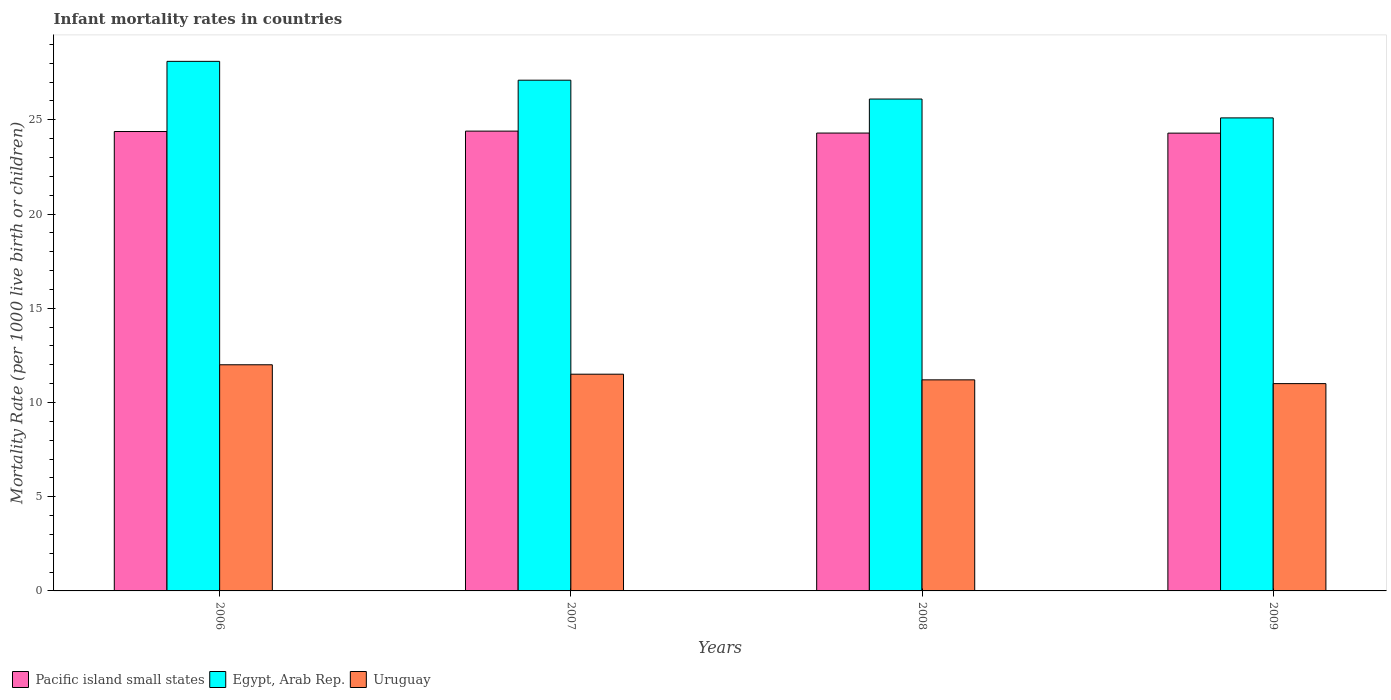How many different coloured bars are there?
Ensure brevity in your answer.  3. How many groups of bars are there?
Your answer should be compact. 4. Are the number of bars on each tick of the X-axis equal?
Offer a very short reply. Yes. How many bars are there on the 2nd tick from the left?
Make the answer very short. 3. What is the label of the 3rd group of bars from the left?
Offer a terse response. 2008. In how many cases, is the number of bars for a given year not equal to the number of legend labels?
Provide a short and direct response. 0. What is the infant mortality rate in Egypt, Arab Rep. in 2007?
Your answer should be very brief. 27.1. Across all years, what is the maximum infant mortality rate in Uruguay?
Offer a very short reply. 12. Across all years, what is the minimum infant mortality rate in Pacific island small states?
Ensure brevity in your answer.  24.29. In which year was the infant mortality rate in Pacific island small states maximum?
Provide a succinct answer. 2007. What is the total infant mortality rate in Pacific island small states in the graph?
Your response must be concise. 97.36. What is the difference between the infant mortality rate in Pacific island small states in 2007 and that in 2008?
Offer a very short reply. 0.1. What is the difference between the infant mortality rate in Egypt, Arab Rep. in 2008 and the infant mortality rate in Pacific island small states in 2009?
Make the answer very short. 1.81. What is the average infant mortality rate in Uruguay per year?
Your response must be concise. 11.43. In the year 2007, what is the difference between the infant mortality rate in Pacific island small states and infant mortality rate in Egypt, Arab Rep.?
Make the answer very short. -2.7. What is the ratio of the infant mortality rate in Egypt, Arab Rep. in 2006 to that in 2008?
Provide a short and direct response. 1.08. Is the infant mortality rate in Egypt, Arab Rep. in 2007 less than that in 2008?
Offer a very short reply. No. What is the difference between the highest and the second highest infant mortality rate in Uruguay?
Offer a very short reply. 0.5. What is the difference between the highest and the lowest infant mortality rate in Pacific island small states?
Give a very brief answer. 0.11. In how many years, is the infant mortality rate in Egypt, Arab Rep. greater than the average infant mortality rate in Egypt, Arab Rep. taken over all years?
Offer a terse response. 2. Is the sum of the infant mortality rate in Pacific island small states in 2008 and 2009 greater than the maximum infant mortality rate in Uruguay across all years?
Offer a very short reply. Yes. What does the 1st bar from the left in 2009 represents?
Give a very brief answer. Pacific island small states. What does the 1st bar from the right in 2007 represents?
Make the answer very short. Uruguay. How many bars are there?
Make the answer very short. 12. What is the difference between two consecutive major ticks on the Y-axis?
Ensure brevity in your answer.  5. Does the graph contain any zero values?
Offer a very short reply. No. Does the graph contain grids?
Offer a terse response. No. How many legend labels are there?
Give a very brief answer. 3. What is the title of the graph?
Offer a very short reply. Infant mortality rates in countries. Does "United Kingdom" appear as one of the legend labels in the graph?
Your answer should be very brief. No. What is the label or title of the X-axis?
Your answer should be very brief. Years. What is the label or title of the Y-axis?
Offer a very short reply. Mortality Rate (per 1000 live birth or children). What is the Mortality Rate (per 1000 live birth or children) of Pacific island small states in 2006?
Ensure brevity in your answer.  24.38. What is the Mortality Rate (per 1000 live birth or children) of Egypt, Arab Rep. in 2006?
Provide a succinct answer. 28.1. What is the Mortality Rate (per 1000 live birth or children) in Uruguay in 2006?
Provide a short and direct response. 12. What is the Mortality Rate (per 1000 live birth or children) in Pacific island small states in 2007?
Your response must be concise. 24.4. What is the Mortality Rate (per 1000 live birth or children) of Egypt, Arab Rep. in 2007?
Offer a very short reply. 27.1. What is the Mortality Rate (per 1000 live birth or children) in Pacific island small states in 2008?
Your answer should be compact. 24.3. What is the Mortality Rate (per 1000 live birth or children) in Egypt, Arab Rep. in 2008?
Provide a short and direct response. 26.1. What is the Mortality Rate (per 1000 live birth or children) in Uruguay in 2008?
Your response must be concise. 11.2. What is the Mortality Rate (per 1000 live birth or children) of Pacific island small states in 2009?
Ensure brevity in your answer.  24.29. What is the Mortality Rate (per 1000 live birth or children) in Egypt, Arab Rep. in 2009?
Provide a succinct answer. 25.1. Across all years, what is the maximum Mortality Rate (per 1000 live birth or children) of Pacific island small states?
Provide a succinct answer. 24.4. Across all years, what is the maximum Mortality Rate (per 1000 live birth or children) in Egypt, Arab Rep.?
Provide a succinct answer. 28.1. Across all years, what is the maximum Mortality Rate (per 1000 live birth or children) in Uruguay?
Your answer should be compact. 12. Across all years, what is the minimum Mortality Rate (per 1000 live birth or children) in Pacific island small states?
Give a very brief answer. 24.29. Across all years, what is the minimum Mortality Rate (per 1000 live birth or children) of Egypt, Arab Rep.?
Your answer should be compact. 25.1. What is the total Mortality Rate (per 1000 live birth or children) in Pacific island small states in the graph?
Your response must be concise. 97.36. What is the total Mortality Rate (per 1000 live birth or children) in Egypt, Arab Rep. in the graph?
Your answer should be compact. 106.4. What is the total Mortality Rate (per 1000 live birth or children) in Uruguay in the graph?
Your response must be concise. 45.7. What is the difference between the Mortality Rate (per 1000 live birth or children) of Pacific island small states in 2006 and that in 2007?
Your answer should be compact. -0.02. What is the difference between the Mortality Rate (per 1000 live birth or children) in Uruguay in 2006 and that in 2007?
Provide a short and direct response. 0.5. What is the difference between the Mortality Rate (per 1000 live birth or children) of Pacific island small states in 2006 and that in 2008?
Keep it short and to the point. 0.08. What is the difference between the Mortality Rate (per 1000 live birth or children) in Pacific island small states in 2006 and that in 2009?
Keep it short and to the point. 0.09. What is the difference between the Mortality Rate (per 1000 live birth or children) of Egypt, Arab Rep. in 2006 and that in 2009?
Offer a terse response. 3. What is the difference between the Mortality Rate (per 1000 live birth or children) in Pacific island small states in 2007 and that in 2008?
Provide a succinct answer. 0.1. What is the difference between the Mortality Rate (per 1000 live birth or children) of Uruguay in 2007 and that in 2008?
Keep it short and to the point. 0.3. What is the difference between the Mortality Rate (per 1000 live birth or children) of Pacific island small states in 2007 and that in 2009?
Keep it short and to the point. 0.11. What is the difference between the Mortality Rate (per 1000 live birth or children) of Egypt, Arab Rep. in 2007 and that in 2009?
Give a very brief answer. 2. What is the difference between the Mortality Rate (per 1000 live birth or children) of Uruguay in 2007 and that in 2009?
Your response must be concise. 0.5. What is the difference between the Mortality Rate (per 1000 live birth or children) of Pacific island small states in 2008 and that in 2009?
Ensure brevity in your answer.  0. What is the difference between the Mortality Rate (per 1000 live birth or children) in Egypt, Arab Rep. in 2008 and that in 2009?
Offer a very short reply. 1. What is the difference between the Mortality Rate (per 1000 live birth or children) in Uruguay in 2008 and that in 2009?
Provide a succinct answer. 0.2. What is the difference between the Mortality Rate (per 1000 live birth or children) in Pacific island small states in 2006 and the Mortality Rate (per 1000 live birth or children) in Egypt, Arab Rep. in 2007?
Give a very brief answer. -2.72. What is the difference between the Mortality Rate (per 1000 live birth or children) in Pacific island small states in 2006 and the Mortality Rate (per 1000 live birth or children) in Uruguay in 2007?
Provide a short and direct response. 12.88. What is the difference between the Mortality Rate (per 1000 live birth or children) in Egypt, Arab Rep. in 2006 and the Mortality Rate (per 1000 live birth or children) in Uruguay in 2007?
Offer a very short reply. 16.6. What is the difference between the Mortality Rate (per 1000 live birth or children) in Pacific island small states in 2006 and the Mortality Rate (per 1000 live birth or children) in Egypt, Arab Rep. in 2008?
Offer a terse response. -1.72. What is the difference between the Mortality Rate (per 1000 live birth or children) of Pacific island small states in 2006 and the Mortality Rate (per 1000 live birth or children) of Uruguay in 2008?
Provide a succinct answer. 13.18. What is the difference between the Mortality Rate (per 1000 live birth or children) of Pacific island small states in 2006 and the Mortality Rate (per 1000 live birth or children) of Egypt, Arab Rep. in 2009?
Ensure brevity in your answer.  -0.72. What is the difference between the Mortality Rate (per 1000 live birth or children) of Pacific island small states in 2006 and the Mortality Rate (per 1000 live birth or children) of Uruguay in 2009?
Provide a short and direct response. 13.38. What is the difference between the Mortality Rate (per 1000 live birth or children) in Pacific island small states in 2007 and the Mortality Rate (per 1000 live birth or children) in Egypt, Arab Rep. in 2008?
Give a very brief answer. -1.7. What is the difference between the Mortality Rate (per 1000 live birth or children) in Pacific island small states in 2007 and the Mortality Rate (per 1000 live birth or children) in Uruguay in 2008?
Ensure brevity in your answer.  13.2. What is the difference between the Mortality Rate (per 1000 live birth or children) in Pacific island small states in 2007 and the Mortality Rate (per 1000 live birth or children) in Egypt, Arab Rep. in 2009?
Your response must be concise. -0.7. What is the difference between the Mortality Rate (per 1000 live birth or children) of Pacific island small states in 2007 and the Mortality Rate (per 1000 live birth or children) of Uruguay in 2009?
Give a very brief answer. 13.4. What is the difference between the Mortality Rate (per 1000 live birth or children) of Egypt, Arab Rep. in 2007 and the Mortality Rate (per 1000 live birth or children) of Uruguay in 2009?
Ensure brevity in your answer.  16.1. What is the difference between the Mortality Rate (per 1000 live birth or children) of Pacific island small states in 2008 and the Mortality Rate (per 1000 live birth or children) of Egypt, Arab Rep. in 2009?
Give a very brief answer. -0.8. What is the difference between the Mortality Rate (per 1000 live birth or children) of Pacific island small states in 2008 and the Mortality Rate (per 1000 live birth or children) of Uruguay in 2009?
Give a very brief answer. 13.3. What is the average Mortality Rate (per 1000 live birth or children) of Pacific island small states per year?
Your answer should be very brief. 24.34. What is the average Mortality Rate (per 1000 live birth or children) of Egypt, Arab Rep. per year?
Give a very brief answer. 26.6. What is the average Mortality Rate (per 1000 live birth or children) of Uruguay per year?
Offer a very short reply. 11.43. In the year 2006, what is the difference between the Mortality Rate (per 1000 live birth or children) in Pacific island small states and Mortality Rate (per 1000 live birth or children) in Egypt, Arab Rep.?
Offer a very short reply. -3.72. In the year 2006, what is the difference between the Mortality Rate (per 1000 live birth or children) of Pacific island small states and Mortality Rate (per 1000 live birth or children) of Uruguay?
Your response must be concise. 12.38. In the year 2006, what is the difference between the Mortality Rate (per 1000 live birth or children) in Egypt, Arab Rep. and Mortality Rate (per 1000 live birth or children) in Uruguay?
Ensure brevity in your answer.  16.1. In the year 2007, what is the difference between the Mortality Rate (per 1000 live birth or children) of Pacific island small states and Mortality Rate (per 1000 live birth or children) of Egypt, Arab Rep.?
Your response must be concise. -2.7. In the year 2007, what is the difference between the Mortality Rate (per 1000 live birth or children) in Pacific island small states and Mortality Rate (per 1000 live birth or children) in Uruguay?
Keep it short and to the point. 12.9. In the year 2008, what is the difference between the Mortality Rate (per 1000 live birth or children) of Pacific island small states and Mortality Rate (per 1000 live birth or children) of Egypt, Arab Rep.?
Provide a short and direct response. -1.8. In the year 2008, what is the difference between the Mortality Rate (per 1000 live birth or children) in Pacific island small states and Mortality Rate (per 1000 live birth or children) in Uruguay?
Your response must be concise. 13.1. In the year 2008, what is the difference between the Mortality Rate (per 1000 live birth or children) in Egypt, Arab Rep. and Mortality Rate (per 1000 live birth or children) in Uruguay?
Your answer should be compact. 14.9. In the year 2009, what is the difference between the Mortality Rate (per 1000 live birth or children) in Pacific island small states and Mortality Rate (per 1000 live birth or children) in Egypt, Arab Rep.?
Offer a very short reply. -0.81. In the year 2009, what is the difference between the Mortality Rate (per 1000 live birth or children) of Pacific island small states and Mortality Rate (per 1000 live birth or children) of Uruguay?
Offer a terse response. 13.29. What is the ratio of the Mortality Rate (per 1000 live birth or children) in Pacific island small states in 2006 to that in 2007?
Offer a very short reply. 1. What is the ratio of the Mortality Rate (per 1000 live birth or children) in Egypt, Arab Rep. in 2006 to that in 2007?
Your answer should be very brief. 1.04. What is the ratio of the Mortality Rate (per 1000 live birth or children) of Uruguay in 2006 to that in 2007?
Your answer should be compact. 1.04. What is the ratio of the Mortality Rate (per 1000 live birth or children) in Egypt, Arab Rep. in 2006 to that in 2008?
Provide a short and direct response. 1.08. What is the ratio of the Mortality Rate (per 1000 live birth or children) in Uruguay in 2006 to that in 2008?
Make the answer very short. 1.07. What is the ratio of the Mortality Rate (per 1000 live birth or children) in Pacific island small states in 2006 to that in 2009?
Keep it short and to the point. 1. What is the ratio of the Mortality Rate (per 1000 live birth or children) in Egypt, Arab Rep. in 2006 to that in 2009?
Offer a very short reply. 1.12. What is the ratio of the Mortality Rate (per 1000 live birth or children) in Egypt, Arab Rep. in 2007 to that in 2008?
Your response must be concise. 1.04. What is the ratio of the Mortality Rate (per 1000 live birth or children) of Uruguay in 2007 to that in 2008?
Your answer should be very brief. 1.03. What is the ratio of the Mortality Rate (per 1000 live birth or children) of Pacific island small states in 2007 to that in 2009?
Keep it short and to the point. 1. What is the ratio of the Mortality Rate (per 1000 live birth or children) in Egypt, Arab Rep. in 2007 to that in 2009?
Offer a very short reply. 1.08. What is the ratio of the Mortality Rate (per 1000 live birth or children) in Uruguay in 2007 to that in 2009?
Your response must be concise. 1.05. What is the ratio of the Mortality Rate (per 1000 live birth or children) of Egypt, Arab Rep. in 2008 to that in 2009?
Your answer should be very brief. 1.04. What is the ratio of the Mortality Rate (per 1000 live birth or children) of Uruguay in 2008 to that in 2009?
Offer a terse response. 1.02. What is the difference between the highest and the second highest Mortality Rate (per 1000 live birth or children) of Pacific island small states?
Your answer should be compact. 0.02. What is the difference between the highest and the second highest Mortality Rate (per 1000 live birth or children) of Uruguay?
Your response must be concise. 0.5. What is the difference between the highest and the lowest Mortality Rate (per 1000 live birth or children) of Pacific island small states?
Keep it short and to the point. 0.11. What is the difference between the highest and the lowest Mortality Rate (per 1000 live birth or children) of Uruguay?
Your answer should be very brief. 1. 